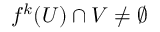<formula> <loc_0><loc_0><loc_500><loc_500>f ^ { k } ( U ) \cap V \neq \emptyset</formula> 